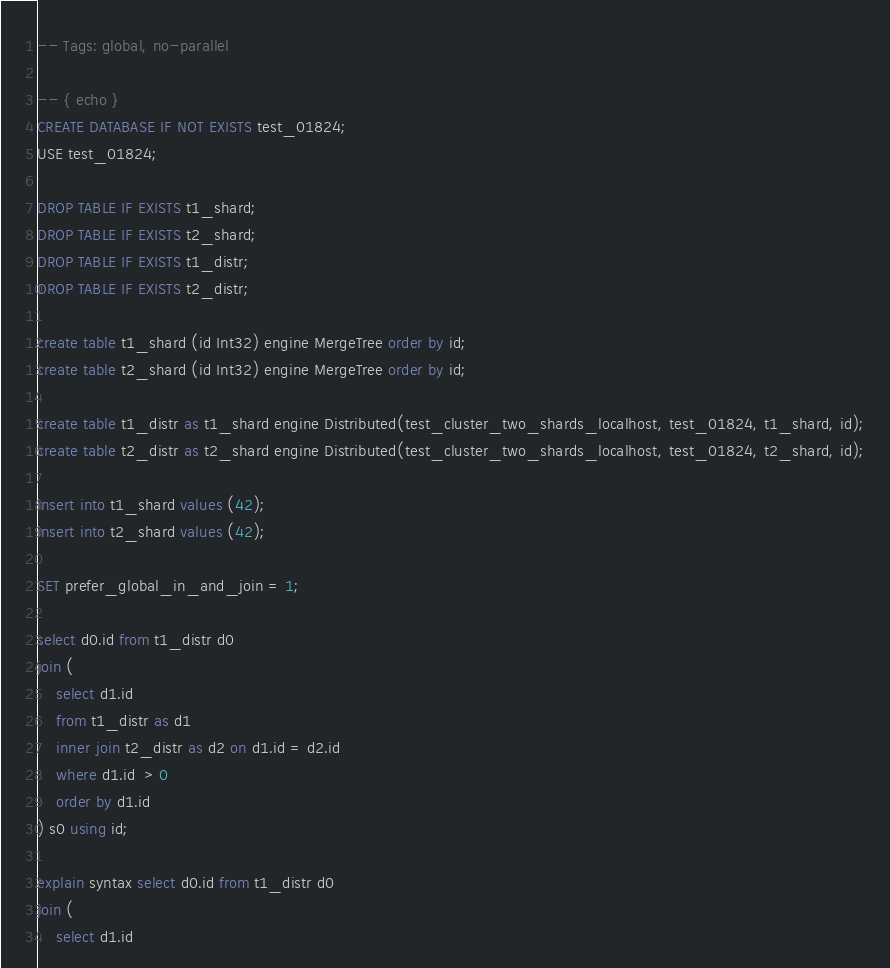Convert code to text. <code><loc_0><loc_0><loc_500><loc_500><_SQL_>-- Tags: global, no-parallel

-- { echo }
CREATE DATABASE IF NOT EXISTS test_01824;
USE test_01824;

DROP TABLE IF EXISTS t1_shard;
DROP TABLE IF EXISTS t2_shard;
DROP TABLE IF EXISTS t1_distr;
DROP TABLE IF EXISTS t2_distr;

create table t1_shard (id Int32) engine MergeTree order by id;
create table t2_shard (id Int32) engine MergeTree order by id;

create table t1_distr as t1_shard engine Distributed(test_cluster_two_shards_localhost, test_01824, t1_shard, id);
create table t2_distr as t2_shard engine Distributed(test_cluster_two_shards_localhost, test_01824, t2_shard, id);

insert into t1_shard values (42);
insert into t2_shard values (42);

SET prefer_global_in_and_join = 1;

select d0.id from t1_distr d0
join (
    select d1.id
    from t1_distr as d1
    inner join t2_distr as d2 on d1.id = d2.id
    where d1.id  > 0
    order by d1.id
) s0 using id;

explain syntax select d0.id from t1_distr d0
join (
    select d1.id</code> 